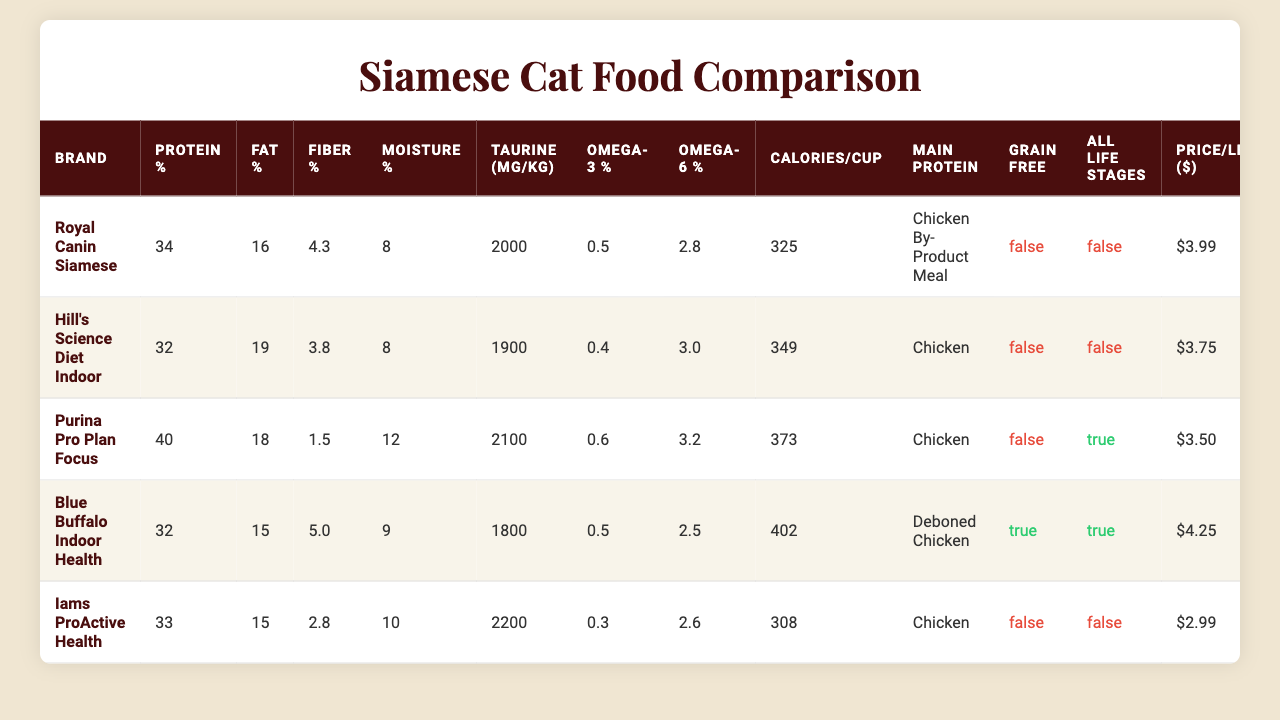What is the protein percentage of Purina Pro Plan Focus? According to the table, the protein percentage for Purina Pro Plan Focus is listed as 40%.
Answer: 40% Which brand has the highest fat percentage? The table shows that Royal Canin Siamese has the highest fat percentage at 16%.
Answer: Royal Canin Siamese How does the fiber percentage of Blue Buffalo Indoor Health compare to Hill's Science Diet Indoor? Blue Buffalo Indoor Health has a fiber percentage of 5.0%, while Hill's Science Diet Indoor has 3.8%. Therefore, Blue Buffalo has a higher fiber percentage by 1.2%.
Answer: Higher by 1.2% What is the price per pound for Iams ProActive Health? The table lists the price per pound for Iams ProActive Health as $2.99.
Answer: $2.99 Are all the brands grain-free? The table indicates that only Blue Buffalo Indoor Health is grain-free, while the other brands are not. So, not all brands are grain-free.
Answer: No Which food contains the most calories per cup? Upon examining the calories per cup, Blue Buffalo Indoor Health contains the highest amount at 402 calories per cup.
Answer: 402 Is there any brand suitable for all life stages? According to the table, Purina Pro Plan Focus and Blue Buffalo Indoor Health are the only brands suitable for all life stages.
Answer: Yes What is the average protein percentage across all brands? The total protein percentages are (34 + 32 + 40 + 32 + 33) = 171. Dividing this by the number of brands (5) gives an average of 34.2%.
Answer: 34.2% Which brand has the most taurine per kg? From the table, Iams ProActive Health has the highest taurine content with 2200 mg/kg.
Answer: Iams ProActive Health How much higher is the moisture percentage in Purina Pro Plan Focus compared to Royal Canin Siamese? Purina Pro Plan Focus has 12% moisture, while Royal Canin Siamese has 8%. The difference is 12% - 8% = 4%.
Answer: 4% 